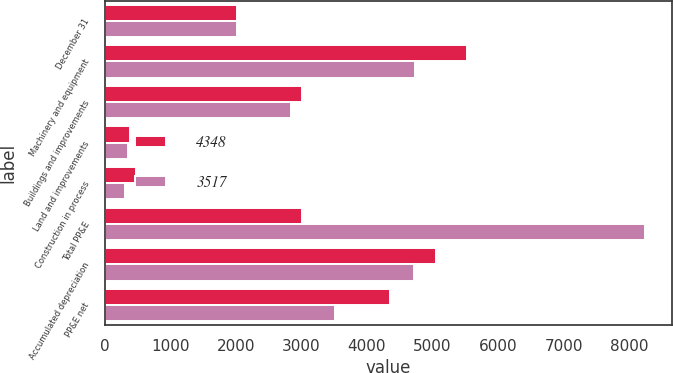<chart> <loc_0><loc_0><loc_500><loc_500><stacked_bar_chart><ecel><fcel>December 31<fcel>Machinery and equipment<fcel>Buildings and improvements<fcel>Land and improvements<fcel>Construction in process<fcel>Total PP&E<fcel>Accumulated depreciation<fcel>PP&E net<nl><fcel>4348<fcel>2018<fcel>5534<fcel>3011<fcel>386<fcel>472<fcel>3011<fcel>5055<fcel>4348<nl><fcel>3517<fcel>2017<fcel>4736<fcel>2837<fcel>357<fcel>307<fcel>8237<fcel>4720<fcel>3517<nl></chart> 